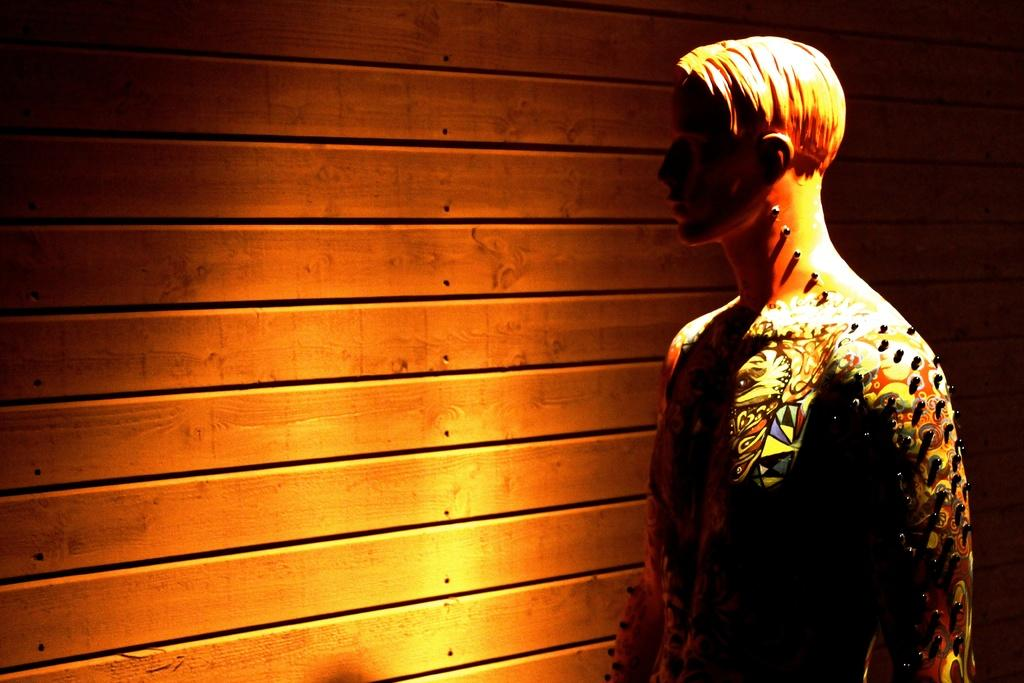What is the main subject in the image? There is a statue in the image. Can you describe the setting of the image? There is a wall in the background of the image. What type of advertisement can be seen on the statue in the image? There is no advertisement present on the statue in the image. How does the snow affect the appearance of the statue in the image? There is no snow present in the image, so it does not affect the appearance of the statue. 